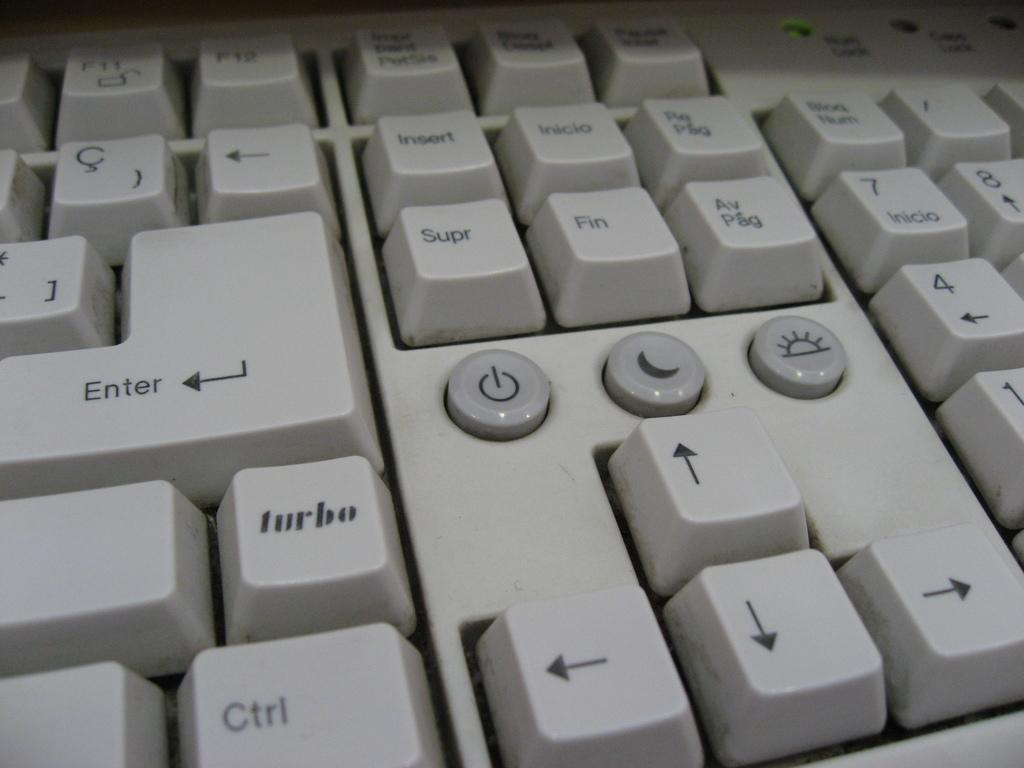What is the main object in the image? There is a keyboard in the image. What can be observed about the key buttons on the keyboard? The key buttons on the keyboard have black color text and numbers. How does the calculator help with income in the image? There is no calculator present in the image, and therefore no information about income can be derived from the image. 